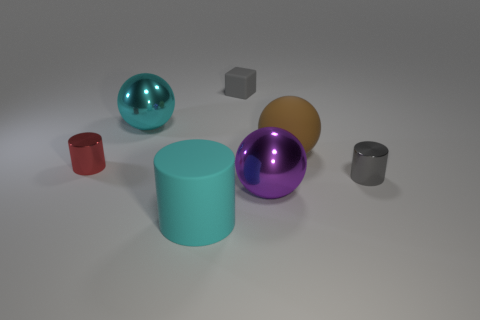Could these objects serve a functional purpose in a real-world setting? While they resemble common household or industrial items, their purpose in this context is likely purely decorative or instructional for displaying lighting and material effects. However, in a real-world setting, objects like these could serve various functions such as containers, weights, or children's play blocks. 